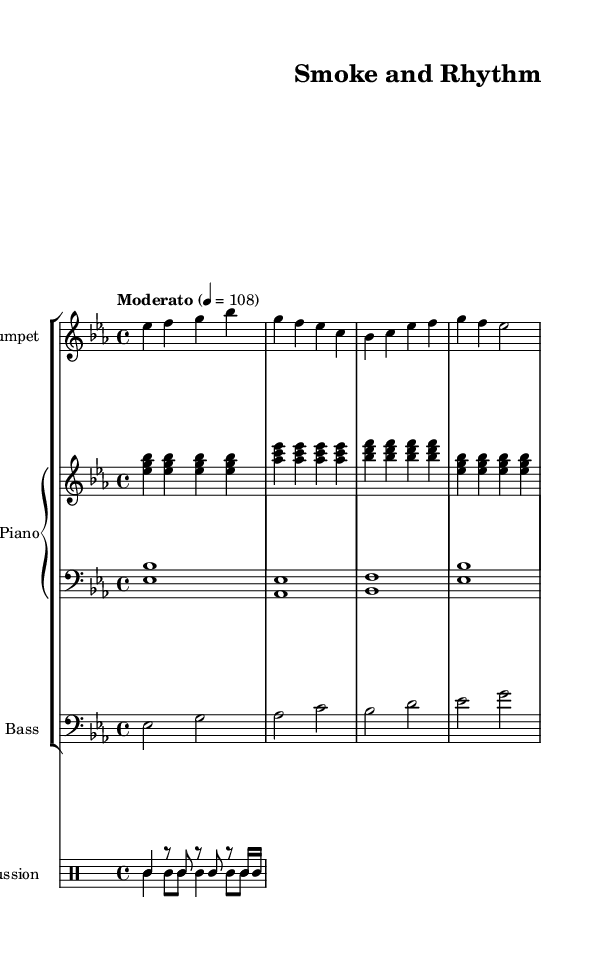What is the key signature of this music? The key signature is E flat major, which has three flats represented by the B flat, E flat, and A flat notes.
Answer: E flat major What is the time signature of the piece? The time signature is indicated by the '4/4' notation at the beginning, meaning there are four beats in every measure and the quarter note gets one beat.
Answer: 4/4 What is the tempo marking for this piece? The tempo marking shown is "Moderato" followed by a metronome marking of 108, indicating a moderate speed for the piece at 108 beats per minute.
Answer: Moderato, 108 How many instruments are featured in this composition? By examining the score, there are four distinct instruments: trumpet, piano (with both right and left hands), bass, and percussion (clave and conga).
Answer: Four What rhythmic patterns are used in the percussion section? The percussion section consists of two patterns: the clave pattern and the conga pattern, which are specified in the drummode notation with their respective rhythms.
Answer: Clave and conga How does the trumpet melody start? The trumpet melody begins with the notes E flat, F, G, and B flat, as indicated in the first measure of the trumpet part.
Answer: E flat, F, G, B flat Which section is likely inspired by cigar-making traditions? The overall jazz style fused with Afro-Cuban elements, particularly in the rhythmic patterns and melodic phrases, reflects the cultural significance linked to cigar-making traditions in Afro-Cuban jazz.
Answer: Afro-Cuban jazz 